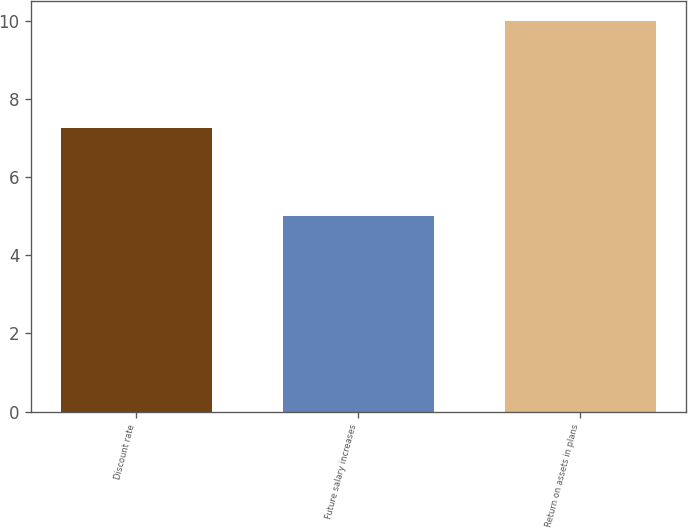Convert chart to OTSL. <chart><loc_0><loc_0><loc_500><loc_500><bar_chart><fcel>Discount rate<fcel>Future salary increases<fcel>Return on assets in plans<nl><fcel>7.25<fcel>5<fcel>10<nl></chart> 